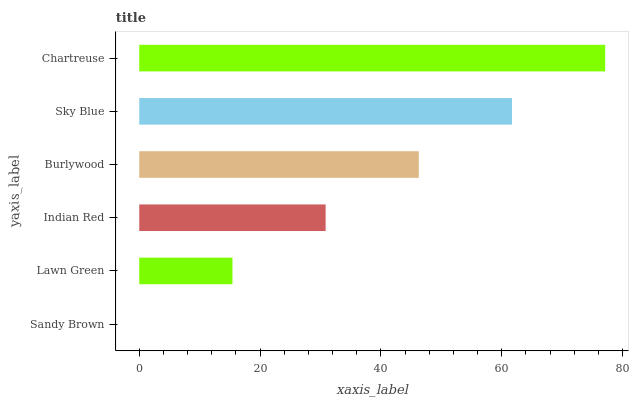Is Sandy Brown the minimum?
Answer yes or no. Yes. Is Chartreuse the maximum?
Answer yes or no. Yes. Is Lawn Green the minimum?
Answer yes or no. No. Is Lawn Green the maximum?
Answer yes or no. No. Is Lawn Green greater than Sandy Brown?
Answer yes or no. Yes. Is Sandy Brown less than Lawn Green?
Answer yes or no. Yes. Is Sandy Brown greater than Lawn Green?
Answer yes or no. No. Is Lawn Green less than Sandy Brown?
Answer yes or no. No. Is Burlywood the high median?
Answer yes or no. Yes. Is Indian Red the low median?
Answer yes or no. Yes. Is Indian Red the high median?
Answer yes or no. No. Is Chartreuse the low median?
Answer yes or no. No. 